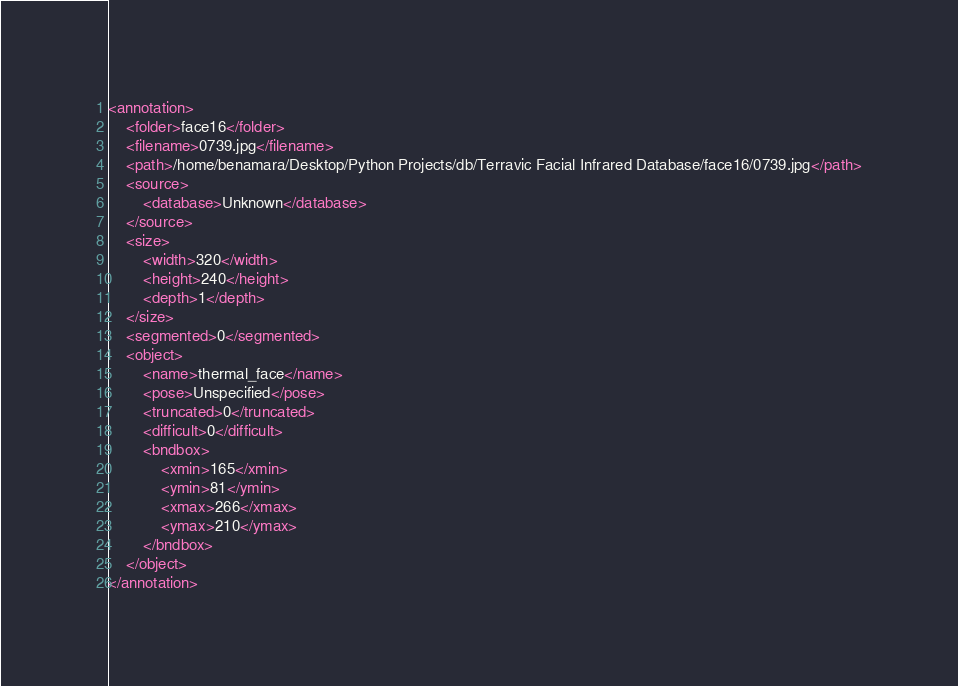<code> <loc_0><loc_0><loc_500><loc_500><_XML_><annotation>
	<folder>face16</folder>
	<filename>0739.jpg</filename>
	<path>/home/benamara/Desktop/Python Projects/db/Terravic Facial Infrared Database/face16/0739.jpg</path>
	<source>
		<database>Unknown</database>
	</source>
	<size>
		<width>320</width>
		<height>240</height>
		<depth>1</depth>
	</size>
	<segmented>0</segmented>
	<object>
		<name>thermal_face</name>
		<pose>Unspecified</pose>
		<truncated>0</truncated>
		<difficult>0</difficult>
		<bndbox>
			<xmin>165</xmin>
			<ymin>81</ymin>
			<xmax>266</xmax>
			<ymax>210</ymax>
		</bndbox>
	</object>
</annotation>
</code> 